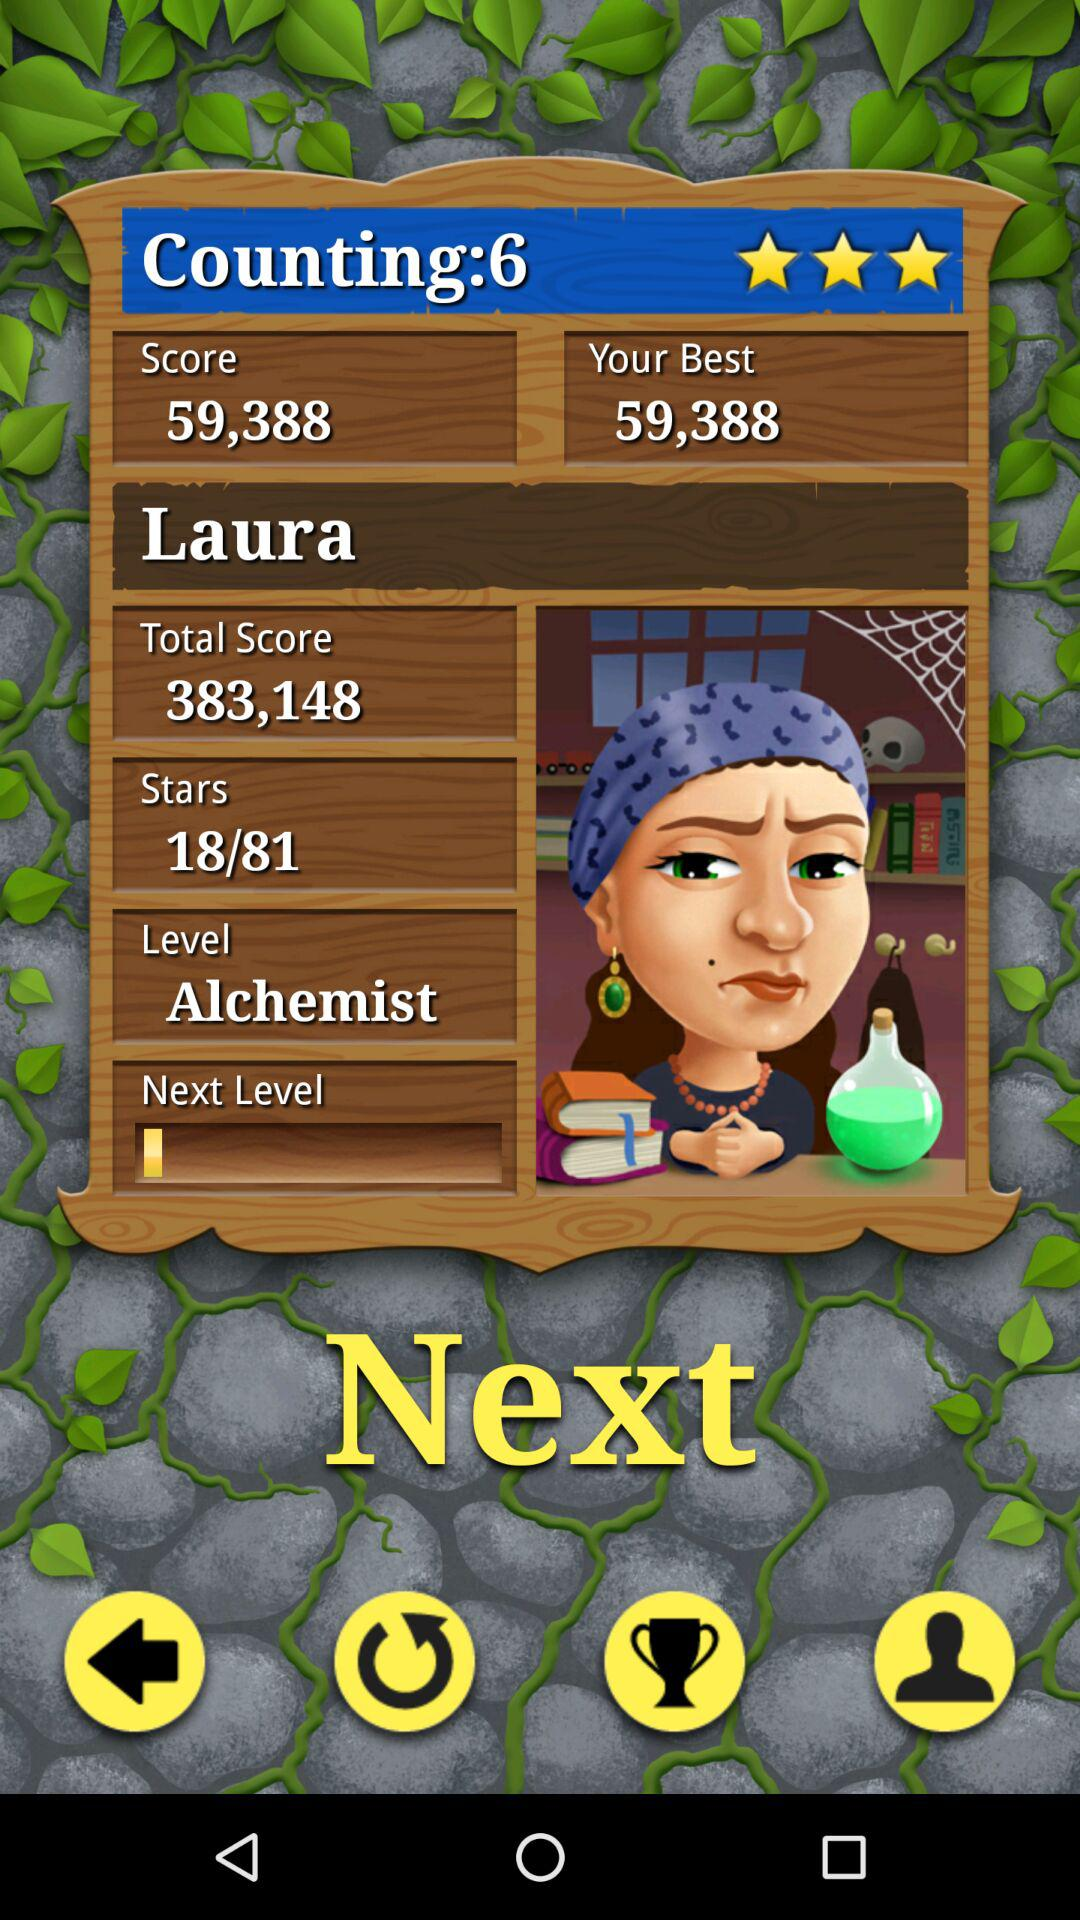What is the total score? The total score is 383,148. 